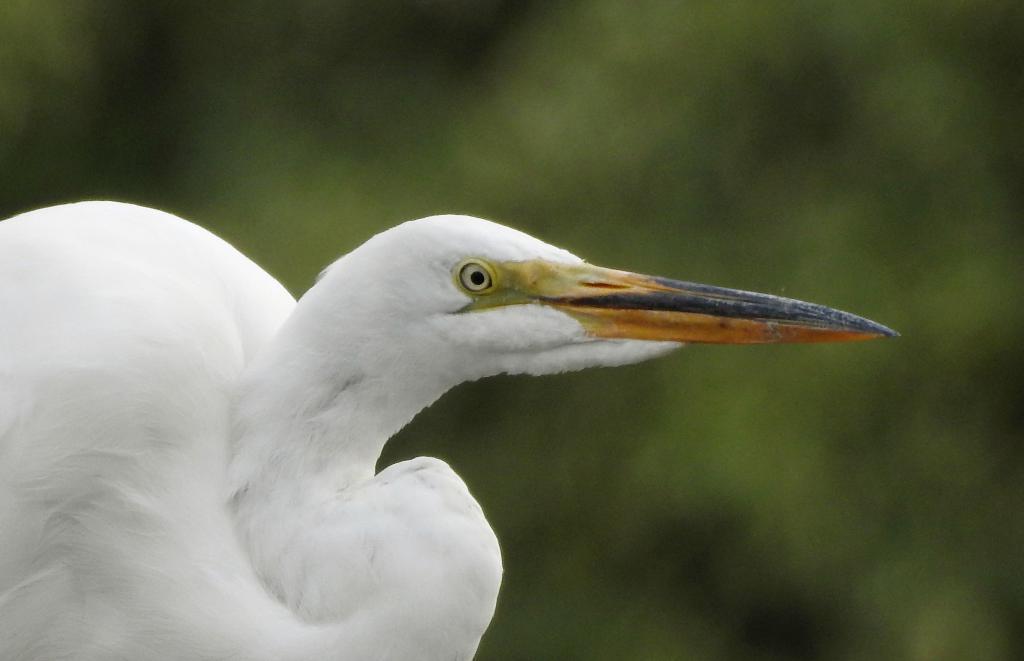In one or two sentences, can you explain what this image depicts? In this image I can see a white colour egret bird in the front and I can see this image is blurry in the background. I can also see green colour in the background. 